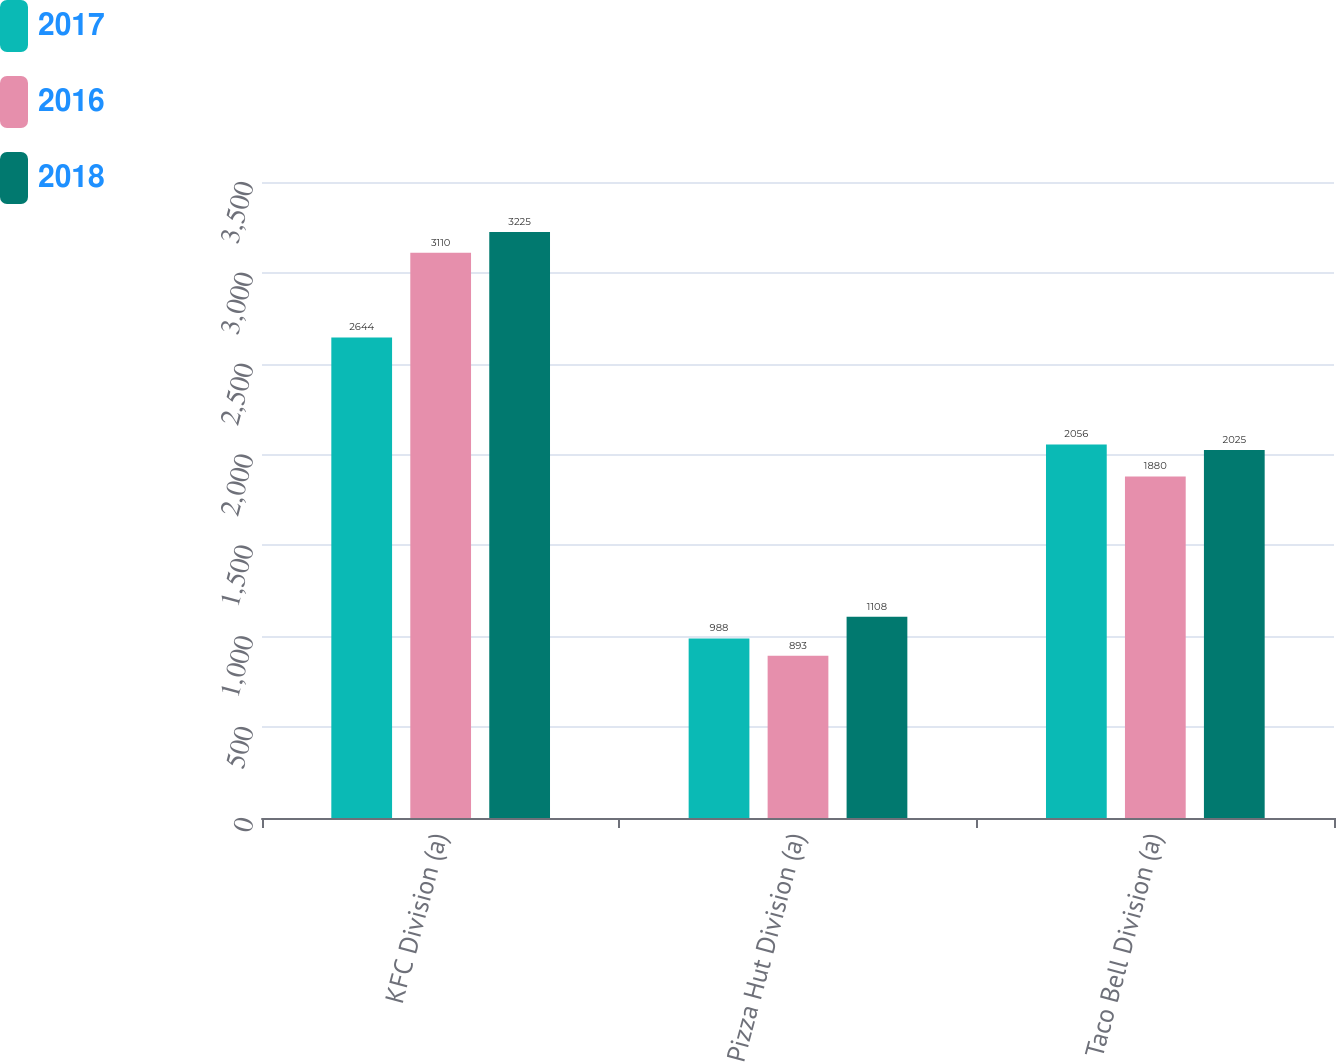Convert chart. <chart><loc_0><loc_0><loc_500><loc_500><stacked_bar_chart><ecel><fcel>KFC Division (a)<fcel>Pizza Hut Division (a)<fcel>Taco Bell Division (a)<nl><fcel>2017<fcel>2644<fcel>988<fcel>2056<nl><fcel>2016<fcel>3110<fcel>893<fcel>1880<nl><fcel>2018<fcel>3225<fcel>1108<fcel>2025<nl></chart> 